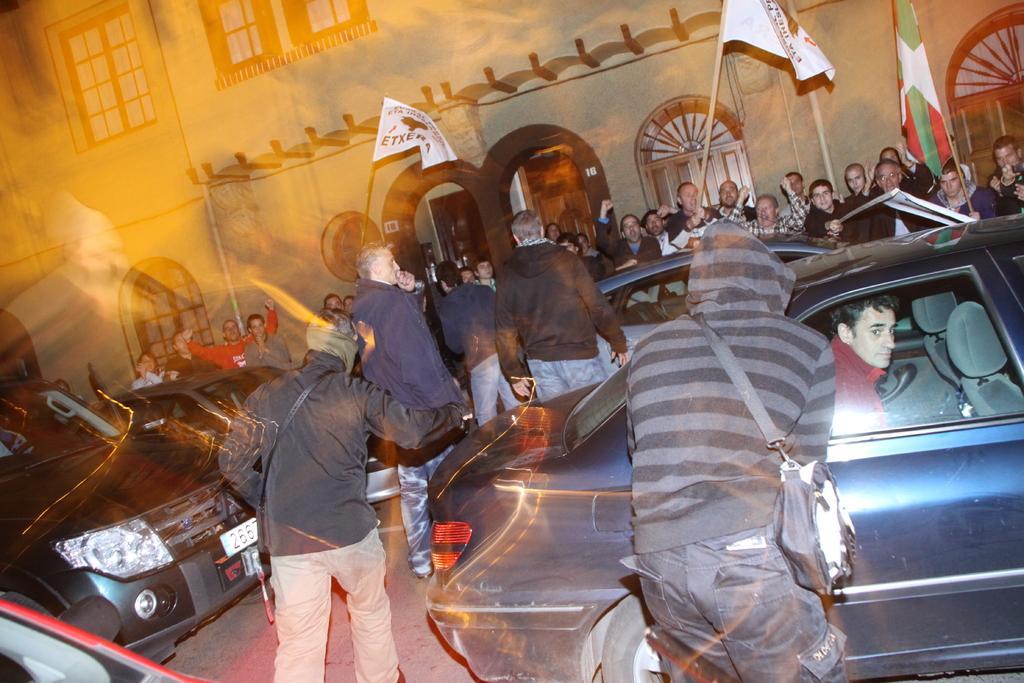Describe this image in one or two sentences. As we can see in the image there are flags, buildings, windows, few people here and there and cars. 